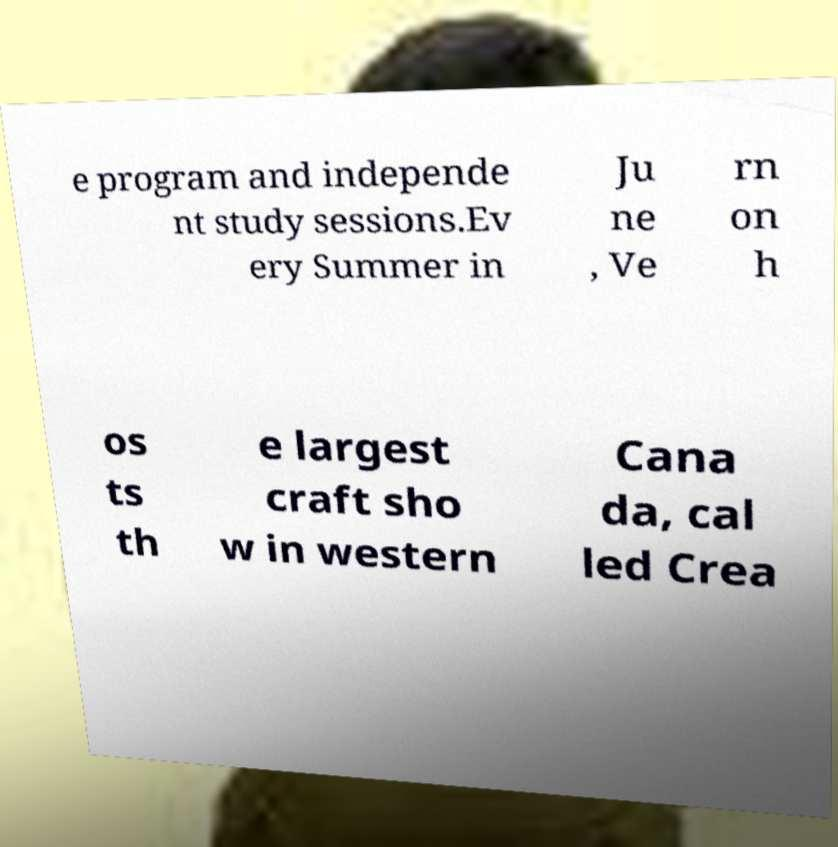Please read and relay the text visible in this image. What does it say? e program and independe nt study sessions.Ev ery Summer in Ju ne , Ve rn on h os ts th e largest craft sho w in western Cana da, cal led Crea 